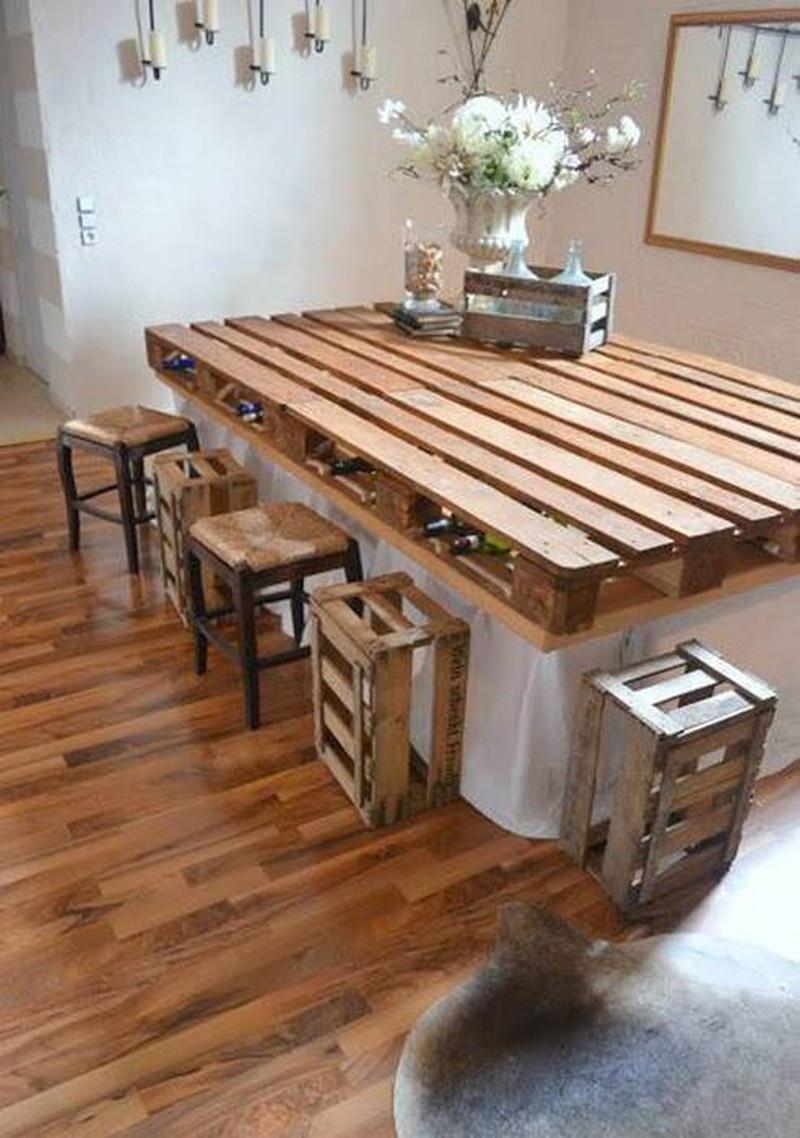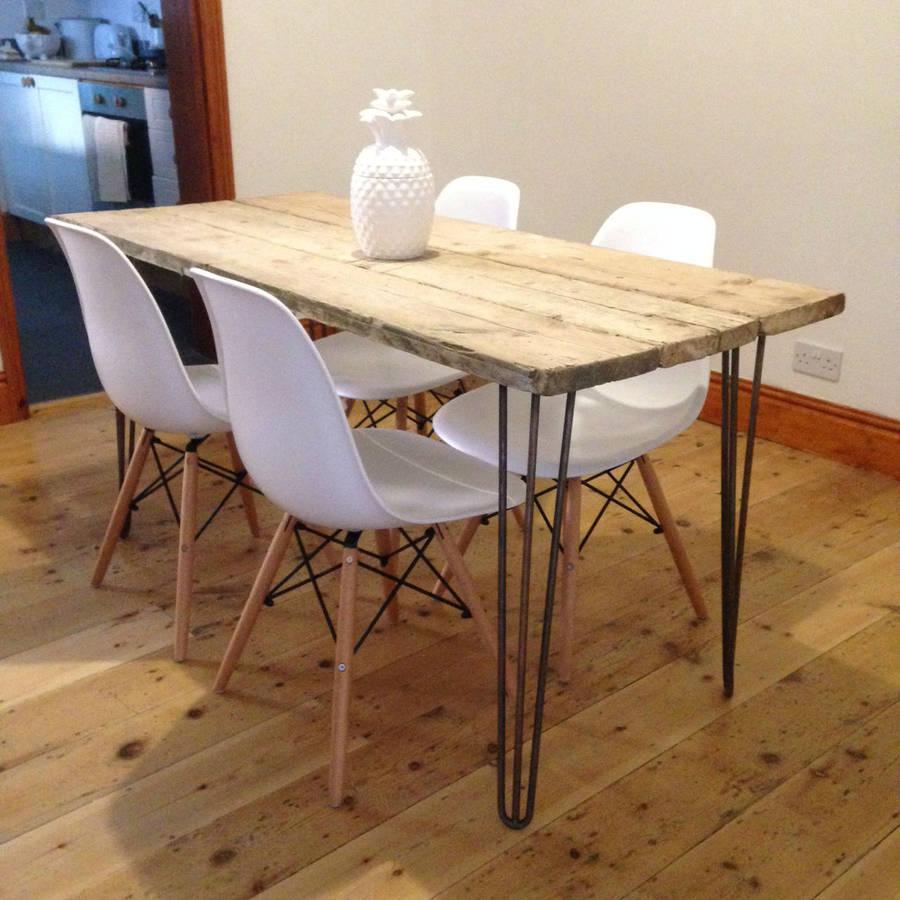The first image is the image on the left, the second image is the image on the right. Given the left and right images, does the statement "There are four chairs in the image on the right." hold true? Answer yes or no. Yes. 